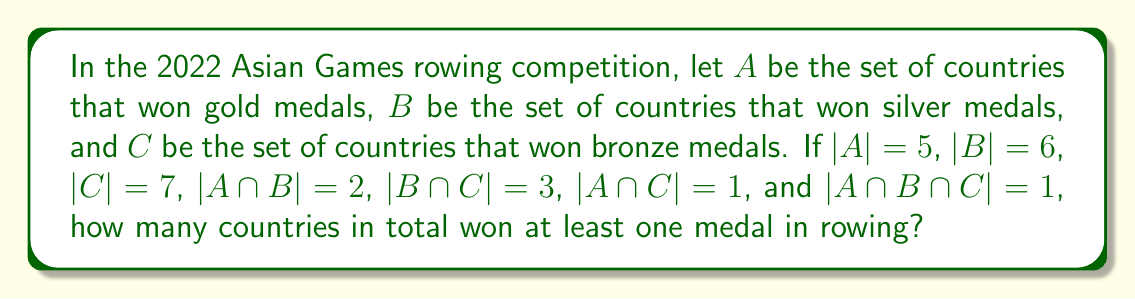Can you answer this question? To solve this problem, we'll use the principle of inclusion-exclusion for three sets. The formula for the number of elements in the union of three sets is:

$$|A \cup B \cup C| = |A| + |B| + |C| - |A \cap B| - |B \cap C| - |A \cap C| + |A \cap B \cap C|$$

Let's substitute the given values:

1. $|A| = 5$
2. $|B| = 6$
3. $|C| = 7$
4. $|A \cap B| = 2$
5. $|B \cap C| = 3$
6. $|A \cap C| = 1$
7. $|A \cap B \cap C| = 1$

Now, let's calculate:

$$|A \cup B \cup C| = 5 + 6 + 7 - 2 - 3 - 1 + 1$$

$$|A \cup B \cup C| = 18 - 6 + 1$$

$$|A \cup B \cup C| = 13$$

Therefore, 13 countries won at least one medal in rowing at the 2022 Asian Games.
Answer: 13 countries 